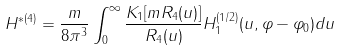<formula> <loc_0><loc_0><loc_500><loc_500>H ^ { * ( 4 ) } = \frac { m } { 8 \pi ^ { 3 } } \int _ { 0 } ^ { \infty } \frac { K _ { 1 } [ m R _ { 4 } ( u ) ] } { R _ { 4 } ( u ) } H _ { 1 } ^ { ( 1 / 2 ) } ( u , \varphi - \varphi _ { 0 } ) d u</formula> 